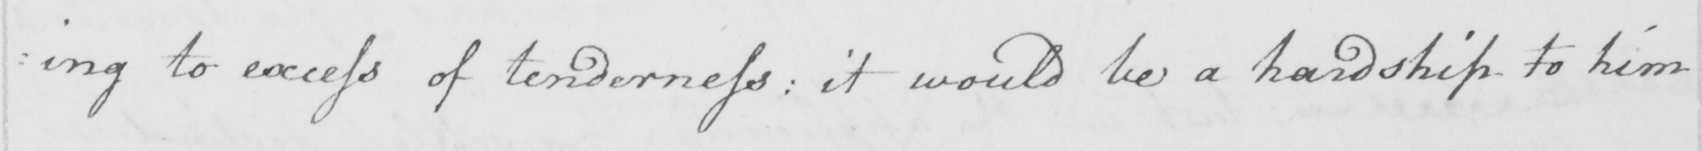Transcribe the text shown in this historical manuscript line. : ing to excess of tenderness :  it would be a hardship to him 